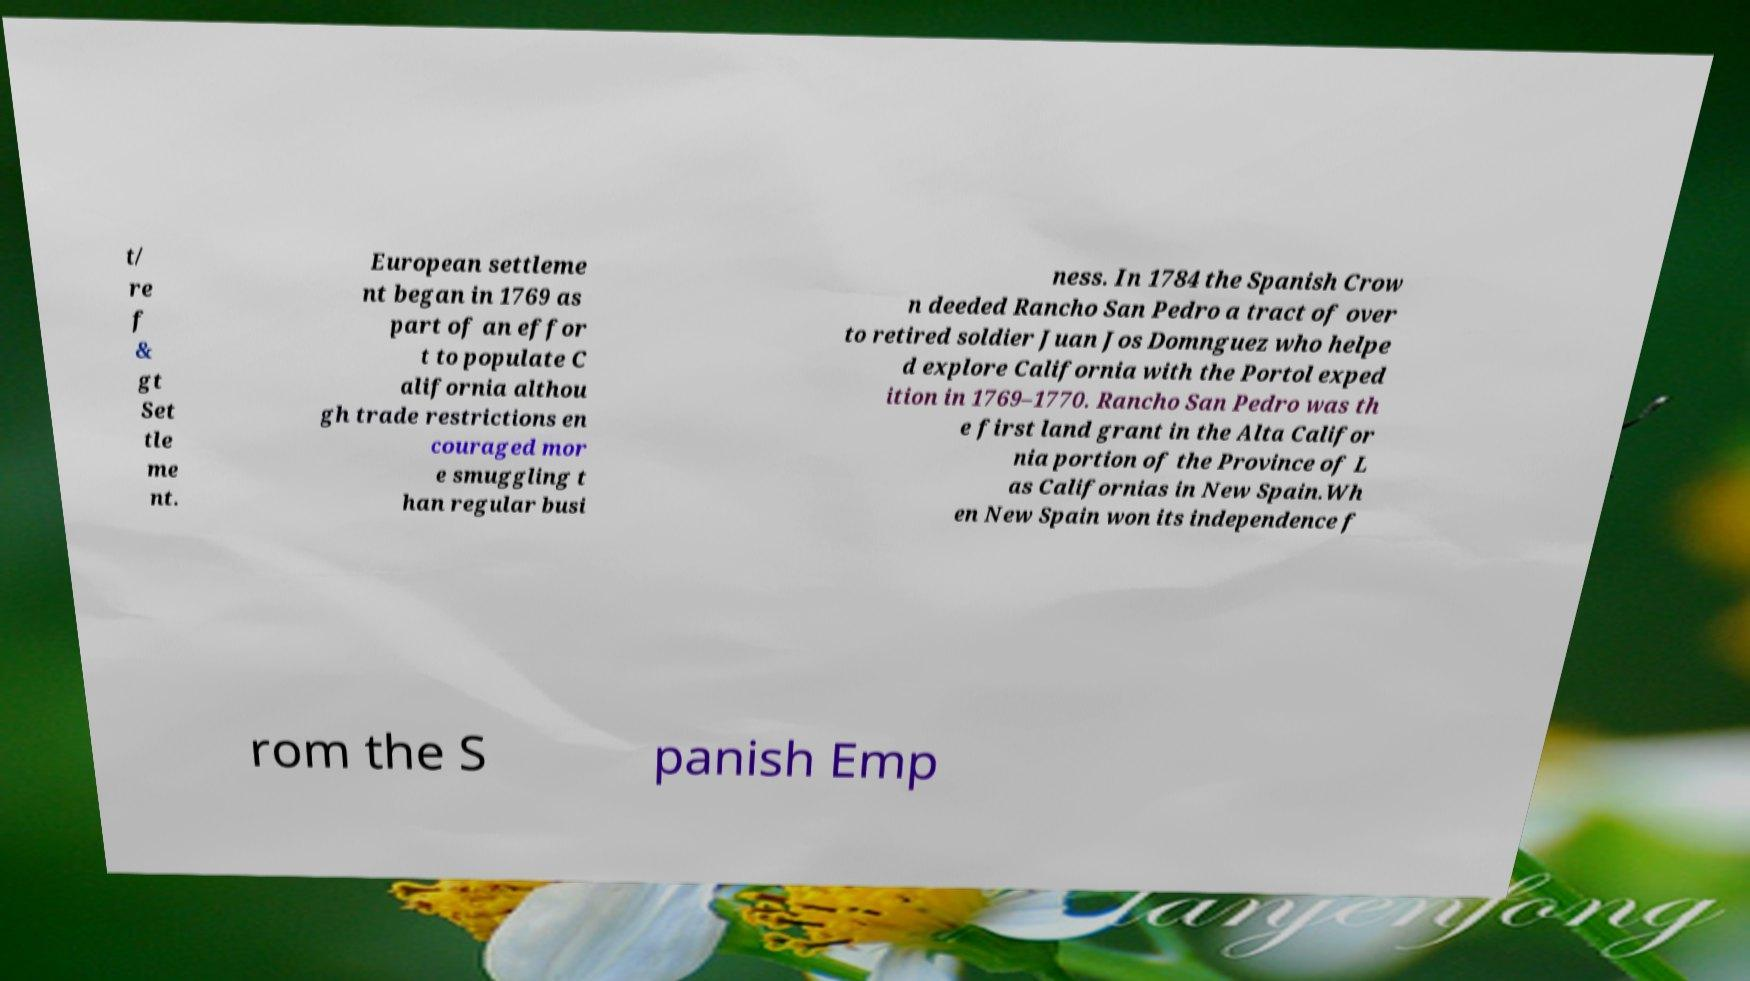Can you read and provide the text displayed in the image?This photo seems to have some interesting text. Can you extract and type it out for me? t/ re f & gt Set tle me nt. European settleme nt began in 1769 as part of an effor t to populate C alifornia althou gh trade restrictions en couraged mor e smuggling t han regular busi ness. In 1784 the Spanish Crow n deeded Rancho San Pedro a tract of over to retired soldier Juan Jos Domnguez who helpe d explore California with the Portol exped ition in 1769–1770. Rancho San Pedro was th e first land grant in the Alta Califor nia portion of the Province of L as Californias in New Spain.Wh en New Spain won its independence f rom the S panish Emp 